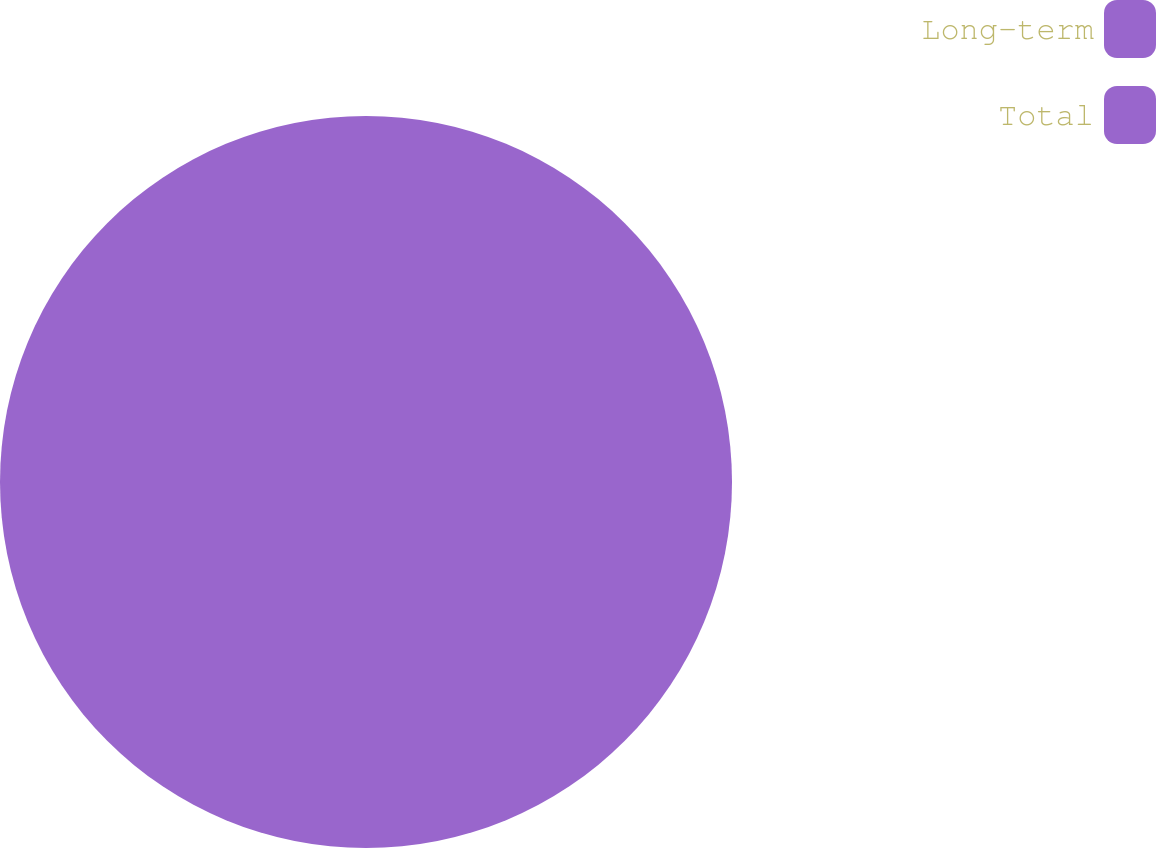Convert chart to OTSL. <chart><loc_0><loc_0><loc_500><loc_500><pie_chart><fcel>Long-term<fcel>Total<nl><fcel>50.0%<fcel>50.0%<nl></chart> 